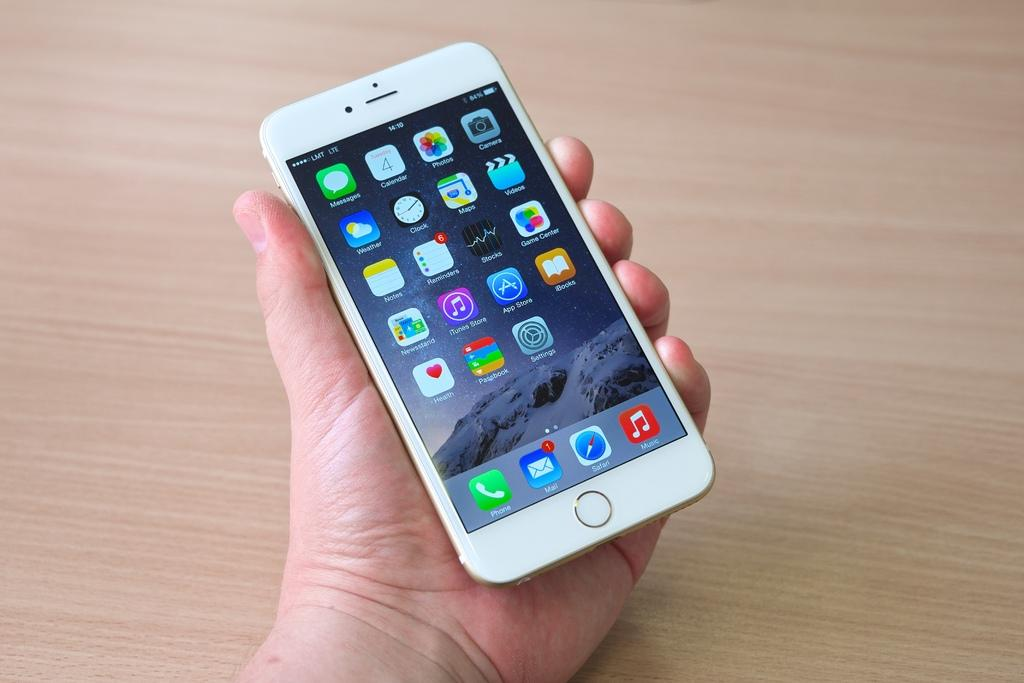<image>
Present a compact description of the photo's key features. a white cell phone with LMT LTE service held in a hand 